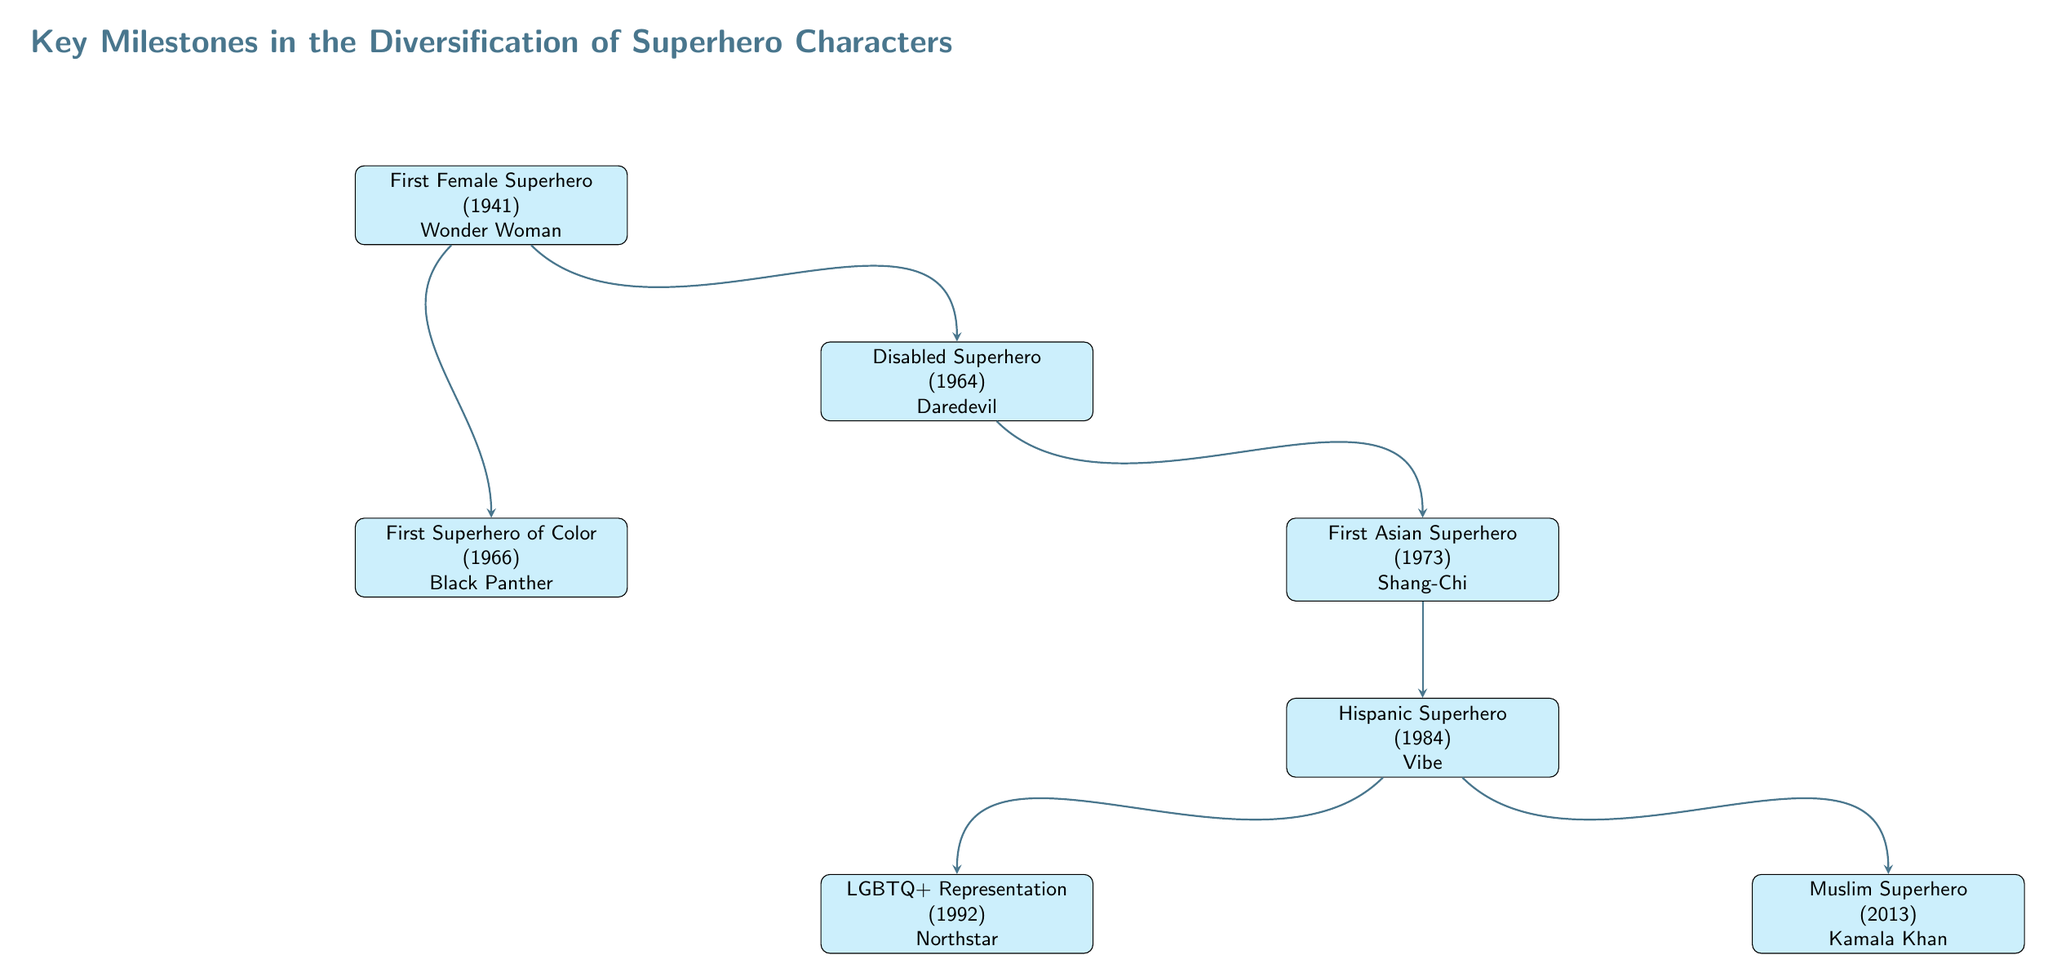What is the first female superhero introduced? The first node in the diagram represents the milestone of the first female superhero, known as Wonder Woman, introduced in 1941.
Answer: Wonder Woman In what year was the first superhero of color introduced? The node labeled "First Superhero of Color" indicates that this milestone occurred in 1966.
Answer: 1966 Which superhero represents the LGBTQ+ community? The "LGBTQ+ Representation" node specifically identifies Northstar as the character representing the LGBTQ+ community, introduced in 1992.
Answer: Northstar What is the relationship between Daredevil and Shang-Chi? The arrows indicate a directional flow from Daredevil to Shang-Chi, suggesting that after the introduction of Daredevil, the next milestone was the debut of Shang-Chi in 1973.
Answer: Next milestone How many characters are depicted in this flow chart? The diagram contains a total of seven nodes, each representing a different milestone in superhero diversification.
Answer: 7 Which character debuted as a Hispanic superhero? The "Hispanic Superhero" node clearly states that Vibe is the character associated with this milestone, introduced in 1984.
Answer: Vibe Which superhero was introduced most recently? The node "Muslim Superhero" indicates that Kamala Khan as Ms. Marvel is the most recent character introduced in this flow chart, with the year being 2013.
Answer: Kamala Khan What do the arrows represent in this diagram? The arrows signify the chronological progression and relationships among the milestones depicted in the flow chart, indicating the developmental sequence of superhero diversification.
Answer: Relationships and progression Which superhero is represented as disabled? The diagram shows that Daredevil is introduced as the disabled superhero in 1964.
Answer: Daredevil 